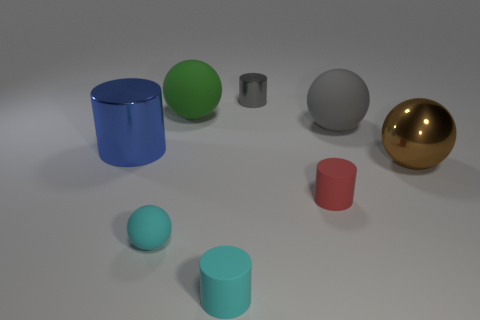What number of balls are either large yellow things or tiny gray shiny objects?
Ensure brevity in your answer.  0. Are there an equal number of shiny balls that are behind the metallic ball and big cylinders to the right of the tiny metal cylinder?
Your response must be concise. Yes. What size is the brown metal object that is the same shape as the big green rubber object?
Offer a terse response. Large. There is a metal thing that is both in front of the large green rubber thing and to the right of the big blue metal object; what size is it?
Make the answer very short. Large. Are there any tiny gray metal things behind the large brown ball?
Provide a short and direct response. Yes. How many things are tiny cylinders that are behind the tiny cyan matte cylinder or small metallic cylinders?
Your answer should be very brief. 2. There is a big shiny thing that is left of the small red cylinder; how many shiny things are in front of it?
Offer a terse response. 1. Are there fewer matte objects in front of the blue metallic cylinder than small cyan objects in front of the cyan ball?
Make the answer very short. No. There is a tiny cyan matte thing that is to the left of the rubber sphere behind the big gray ball; what shape is it?
Your answer should be compact. Sphere. How many other objects are there of the same material as the brown ball?
Provide a succinct answer. 2. 